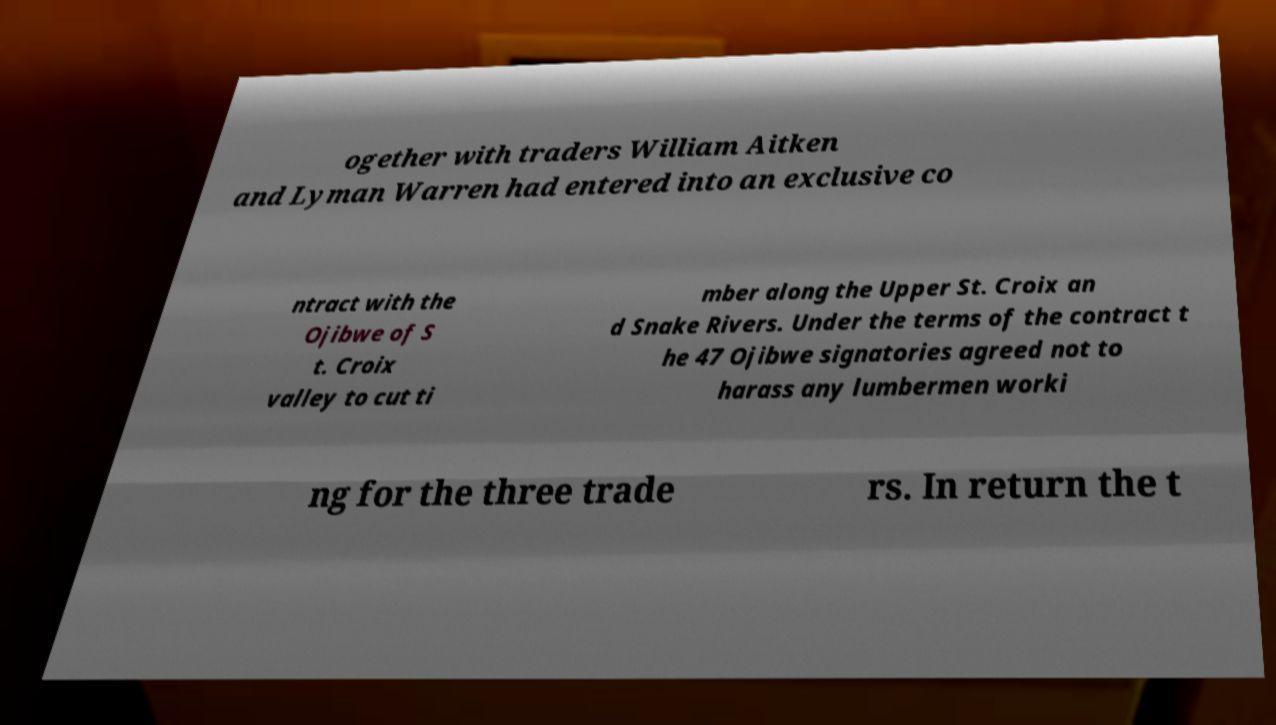There's text embedded in this image that I need extracted. Can you transcribe it verbatim? ogether with traders William Aitken and Lyman Warren had entered into an exclusive co ntract with the Ojibwe of S t. Croix valley to cut ti mber along the Upper St. Croix an d Snake Rivers. Under the terms of the contract t he 47 Ojibwe signatories agreed not to harass any lumbermen worki ng for the three trade rs. In return the t 